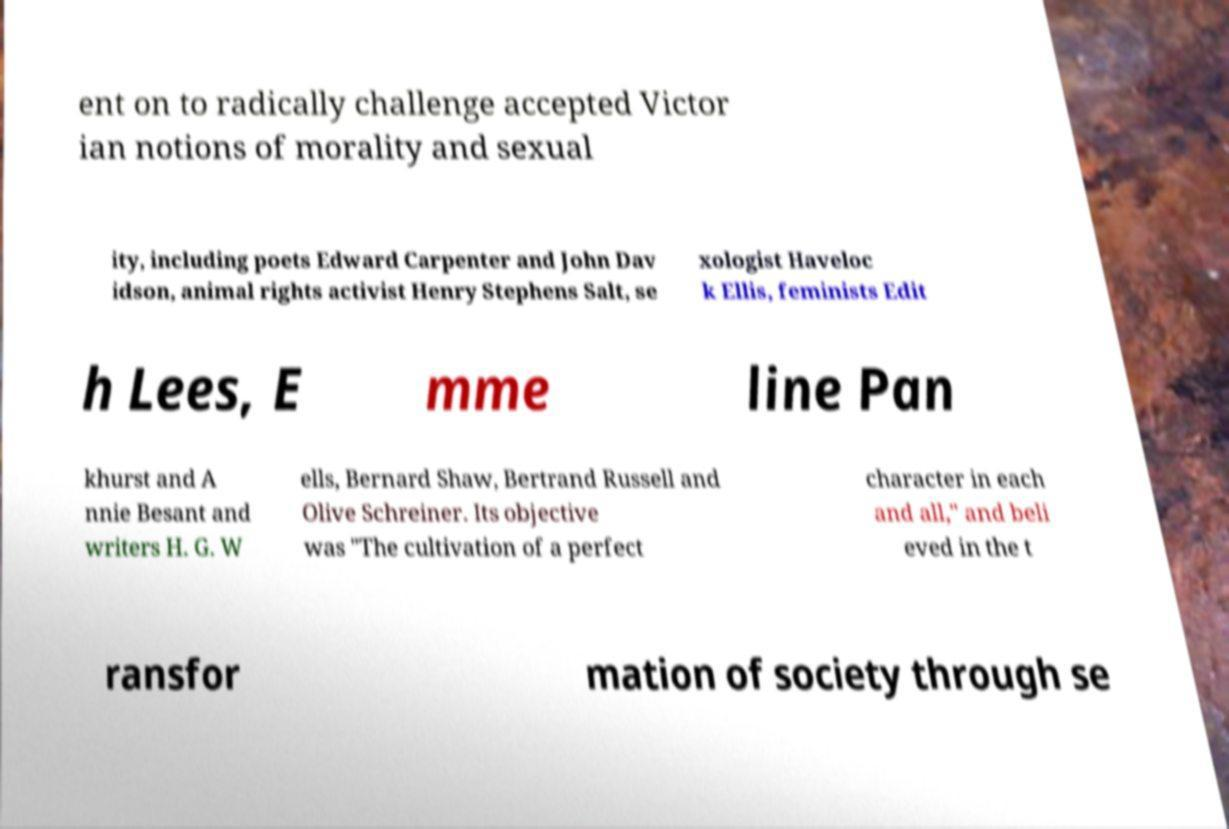There's text embedded in this image that I need extracted. Can you transcribe it verbatim? ent on to radically challenge accepted Victor ian notions of morality and sexual ity, including poets Edward Carpenter and John Dav idson, animal rights activist Henry Stephens Salt, se xologist Haveloc k Ellis, feminists Edit h Lees, E mme line Pan khurst and A nnie Besant and writers H. G. W ells, Bernard Shaw, Bertrand Russell and Olive Schreiner. Its objective was "The cultivation of a perfect character in each and all," and beli eved in the t ransfor mation of society through se 